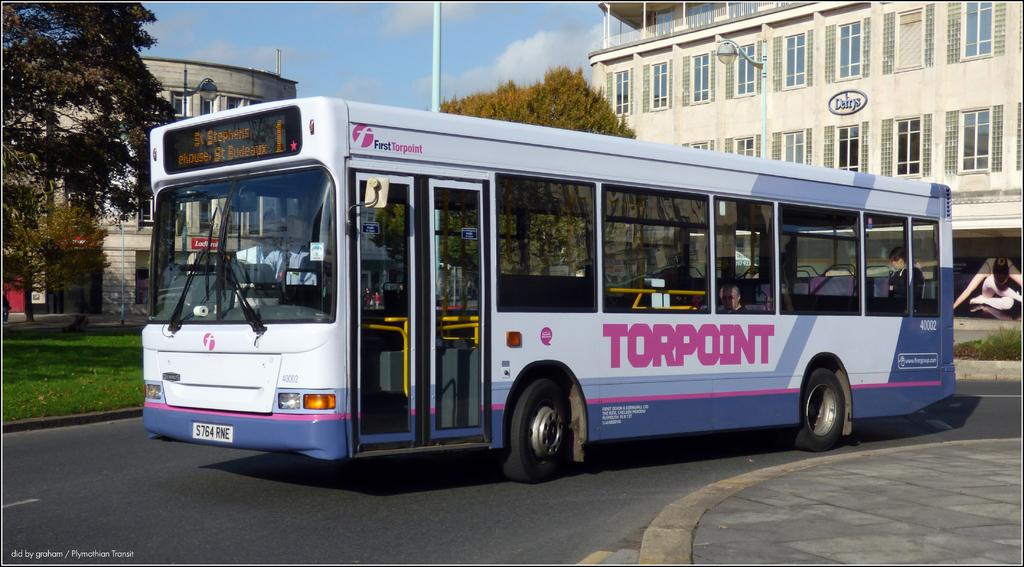<image>
Offer a succinct explanation of the picture presented. A Torpoint but that is driving in the street 